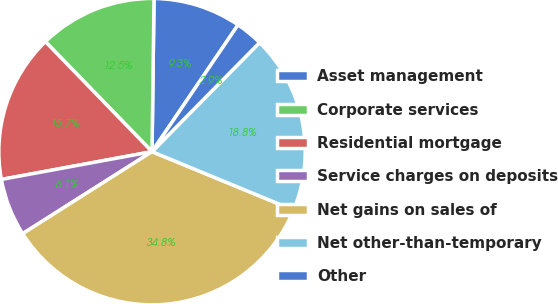<chart> <loc_0><loc_0><loc_500><loc_500><pie_chart><fcel>Asset management<fcel>Corporate services<fcel>Residential mortgage<fcel>Service charges on deposits<fcel>Net gains on sales of<fcel>Net other-than-temporary<fcel>Other<nl><fcel>9.28%<fcel>12.46%<fcel>15.65%<fcel>6.09%<fcel>34.78%<fcel>18.84%<fcel>2.9%<nl></chart> 